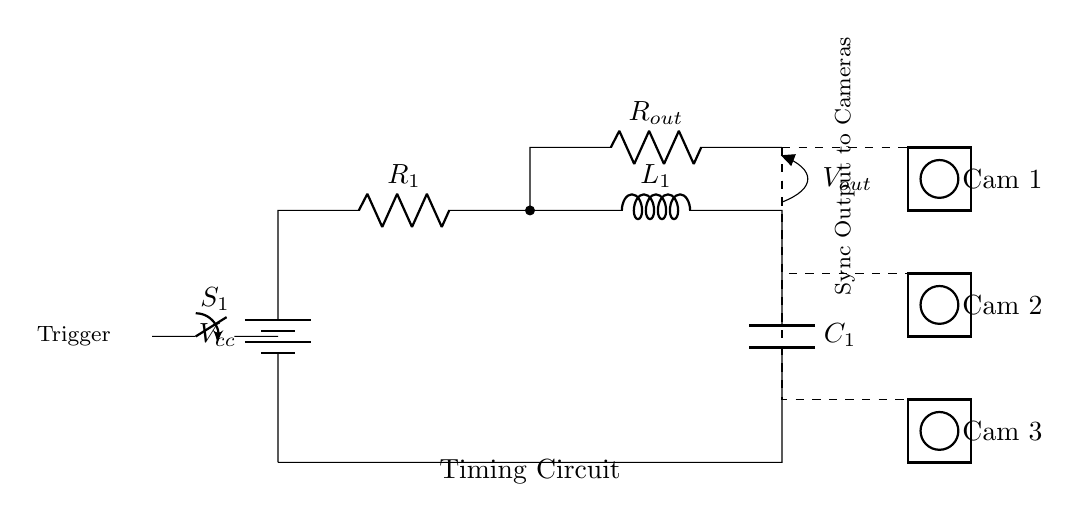What is the voltage from the battery? The voltage from the battery is labeled as Vcc in the circuit diagram, which indicates the power supply voltage.
Answer: Vcc What components are in the timing circuit? The timing circuit consists of a resistor, inductor, and capacitor, as well as a switch and an additional resistor for output.
Answer: Resistor, Inductor, Capacitor How many cameras are connected to the output? There are three cameras connected to the output of the timing circuit, as indicated by their corresponding symbols and connections in the diagram.
Answer: Three What is the function of the switch? The switch serves as a trigger to initiate the timing circuit, allowing the user to control when the synchronization begins for the cameras.
Answer: Trigger What happens when the switch is closed? When the switch is closed, current flows from the battery through the circuit, charging the capacitor and allowing for synchronization signals to be sent to the cameras.
Answer: Current flows to charge the capacitor What type of circuit is this? This is a resistor-inductor-capacitor circuit, commonly used for timing and synchronization applications due to its ability to control timing intervals.
Answer: Resistor-Inductor-Capacitor What is the purpose of the output resistor? The output resistor acts as a load for the timing circuit, helping to regulate the voltage and current sent to the connected cameras for proper operation.
Answer: Regulate voltage and current 